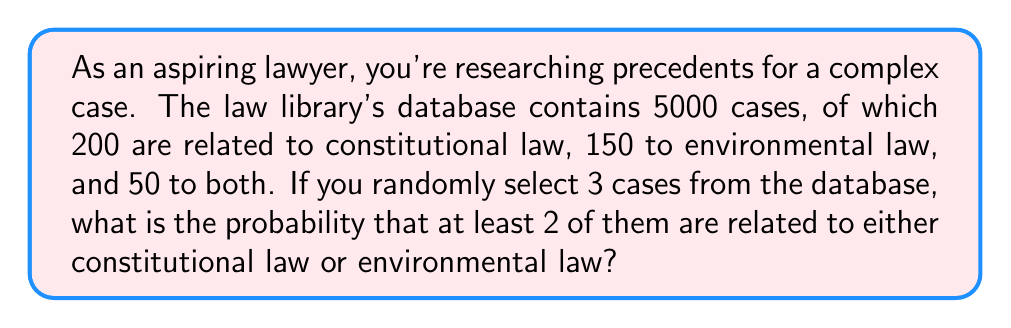Provide a solution to this math problem. Let's approach this step-by-step:

1) First, let's calculate the number of cases related to either constitutional or environmental law:
   $200 + 150 - 50 = 300$ (we subtract 50 to avoid double-counting)

2) Let's define the probability of selecting a relevant case:
   $p = \frac{300}{5000} = 0.06$

3) The probability of selecting a non-relevant case:
   $q = 1 - p = 0.94$

4) We want the probability of at least 2 out of 3 cases being relevant. This can happen in two ways:
   - Exactly 2 out of 3 are relevant
   - All 3 are relevant

5) The probability of exactly 2 out of 3 being relevant:
   $$P(\text{2 relevant}) = \binom{3}{2} \cdot p^2 \cdot q^1 = 3 \cdot 0.06^2 \cdot 0.94 = 0.010044$$

6) The probability of all 3 being relevant:
   $$P(\text{3 relevant}) = p^3 = 0.06^3 = 0.000216$$

7) The total probability is the sum of these two probabilities:
   $$P(\text{at least 2 relevant}) = 0.010044 + 0.000216 = 0.010260$$
Answer: $0.010260$ or approximately $1.026\%$ 